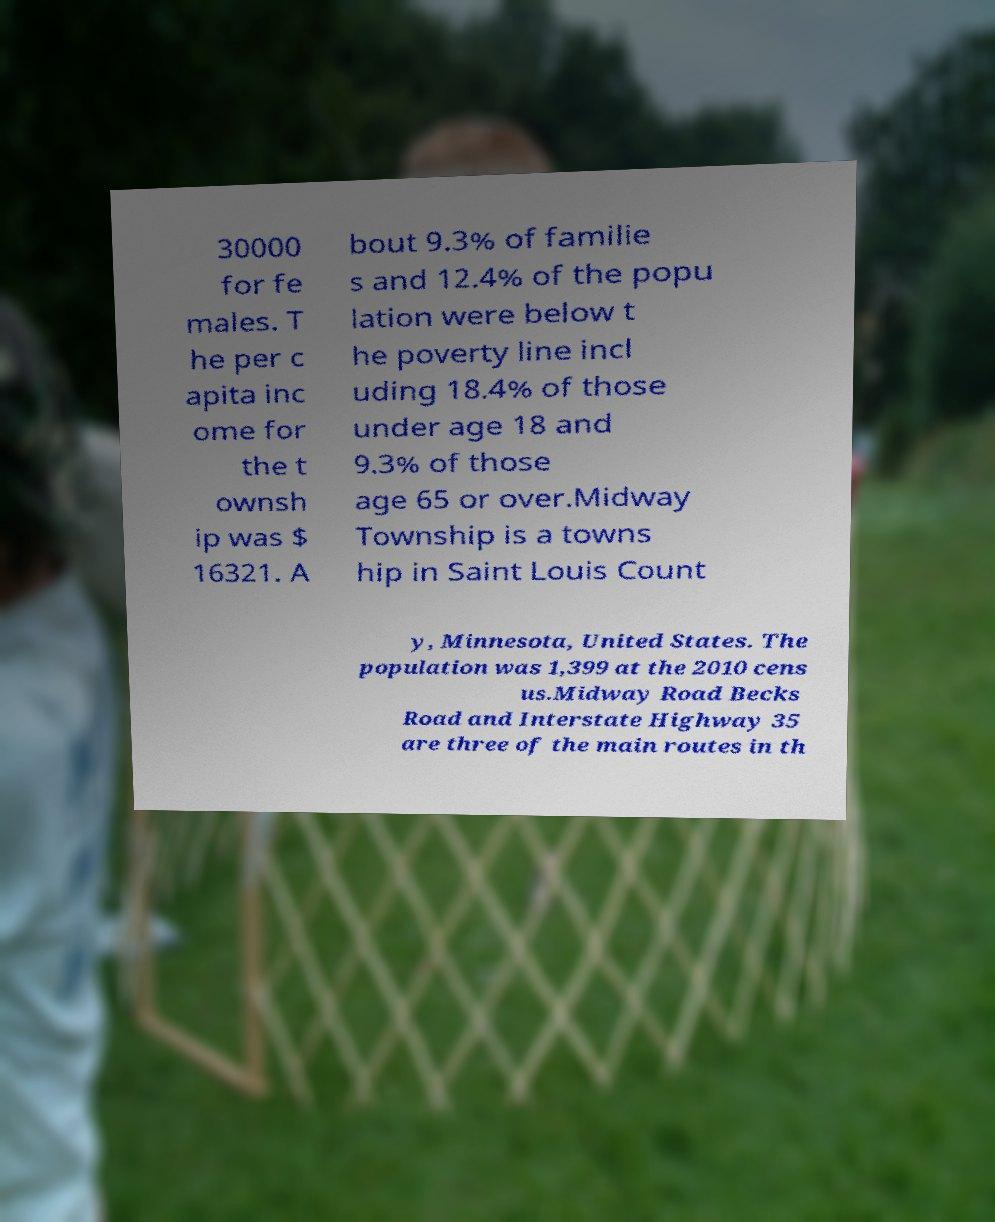Could you assist in decoding the text presented in this image and type it out clearly? 30000 for fe males. T he per c apita inc ome for the t ownsh ip was $ 16321. A bout 9.3% of familie s and 12.4% of the popu lation were below t he poverty line incl uding 18.4% of those under age 18 and 9.3% of those age 65 or over.Midway Township is a towns hip in Saint Louis Count y, Minnesota, United States. The population was 1,399 at the 2010 cens us.Midway Road Becks Road and Interstate Highway 35 are three of the main routes in th 